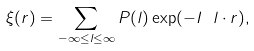Convert formula to latex. <formula><loc_0><loc_0><loc_500><loc_500>\xi ( r ) = \sum _ { - \infty \leq l \leq \infty } P ( l ) \exp ( - I \ l \cdot r ) ,</formula> 